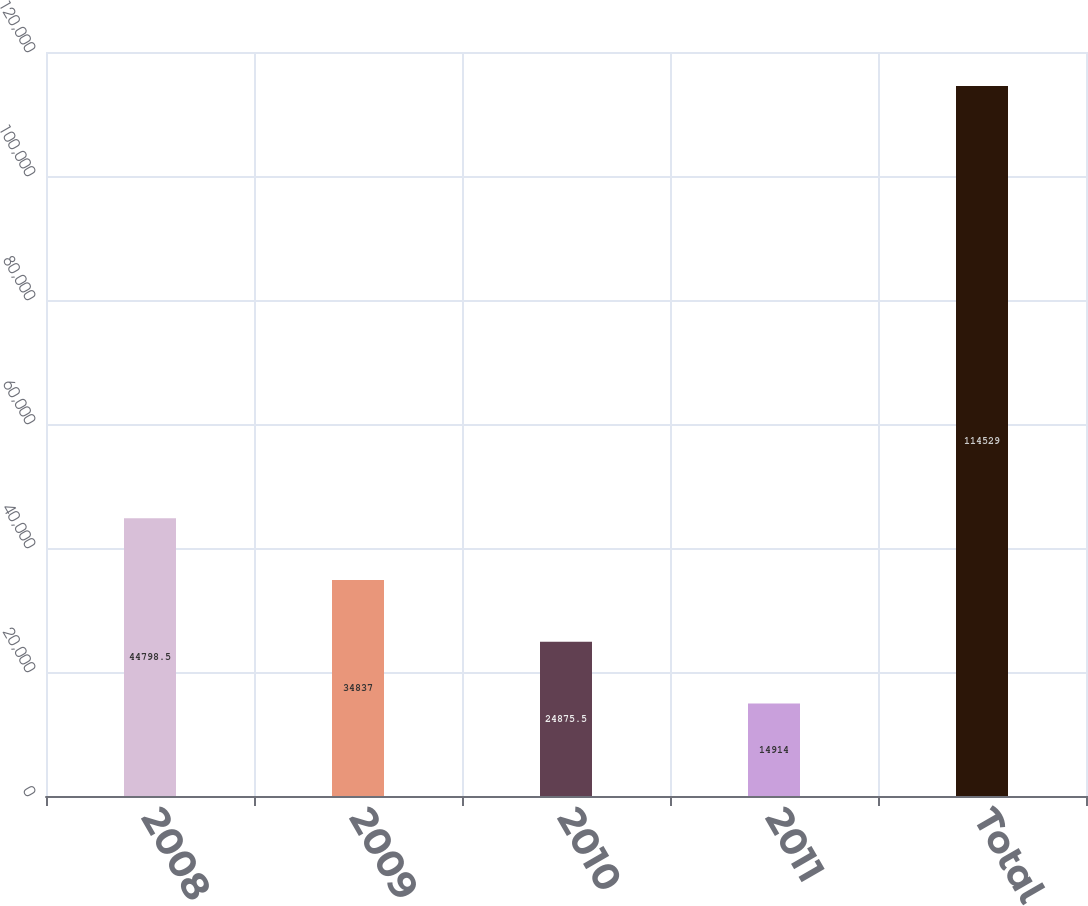Convert chart. <chart><loc_0><loc_0><loc_500><loc_500><bar_chart><fcel>2008<fcel>2009<fcel>2010<fcel>2011<fcel>Total<nl><fcel>44798.5<fcel>34837<fcel>24875.5<fcel>14914<fcel>114529<nl></chart> 